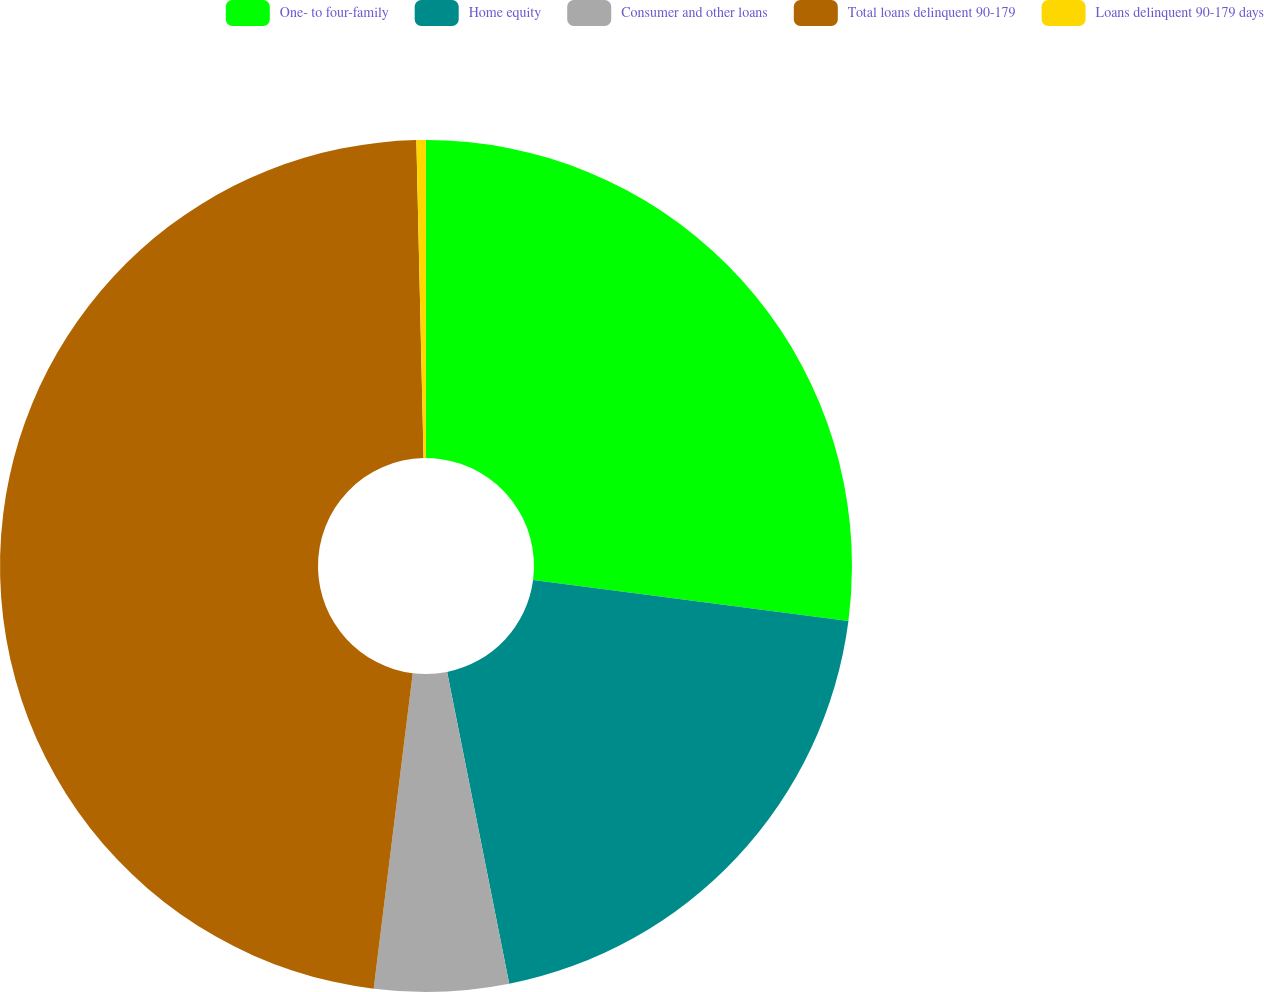Convert chart to OTSL. <chart><loc_0><loc_0><loc_500><loc_500><pie_chart><fcel>One- to four-family<fcel>Home equity<fcel>Consumer and other loans<fcel>Total loans delinquent 90-179<fcel>Loans delinquent 90-179 days<nl><fcel>27.06%<fcel>19.81%<fcel>5.09%<fcel>47.68%<fcel>0.36%<nl></chart> 